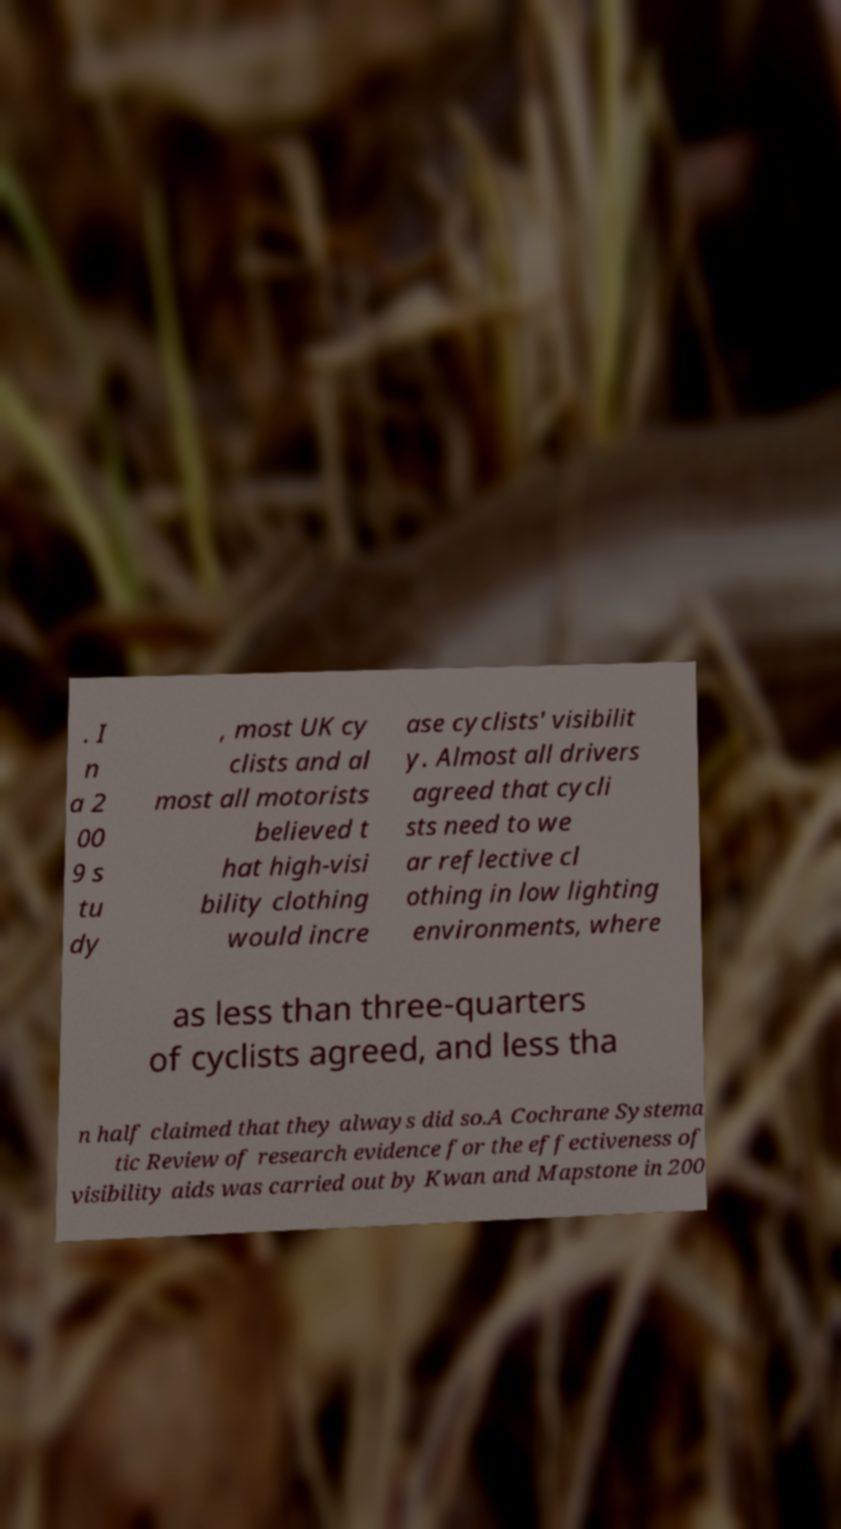Please read and relay the text visible in this image. What does it say? . I n a 2 00 9 s tu dy , most UK cy clists and al most all motorists believed t hat high-visi bility clothing would incre ase cyclists' visibilit y. Almost all drivers agreed that cycli sts need to we ar reflective cl othing in low lighting environments, where as less than three-quarters of cyclists agreed, and less tha n half claimed that they always did so.A Cochrane Systema tic Review of research evidence for the effectiveness of visibility aids was carried out by Kwan and Mapstone in 200 